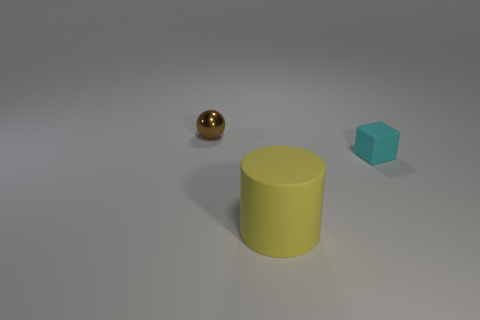The small thing behind the tiny object that is on the right side of the small shiny thing is what shape?
Provide a short and direct response. Sphere. Is the size of the cyan rubber cube the same as the matte object that is left of the small cube?
Your answer should be very brief. No. There is a thing that is behind the tiny cyan thing; what is it made of?
Offer a terse response. Metal. What number of objects are to the left of the small rubber cube and to the right of the brown metal thing?
Your answer should be very brief. 1. There is a brown sphere that is the same size as the cyan rubber cube; what material is it?
Keep it short and to the point. Metal. There is a rubber object that is in front of the small rubber thing; does it have the same size as the object that is left of the large cylinder?
Give a very brief answer. No. Are there any large yellow objects behind the large object?
Keep it short and to the point. No. The small object that is to the left of the rubber object that is on the right side of the big yellow cylinder is what color?
Offer a very short reply. Brown. Are there fewer small gray matte objects than yellow matte cylinders?
Your response must be concise. Yes. How many tiny cyan rubber things have the same shape as the big yellow object?
Your answer should be very brief. 0. 